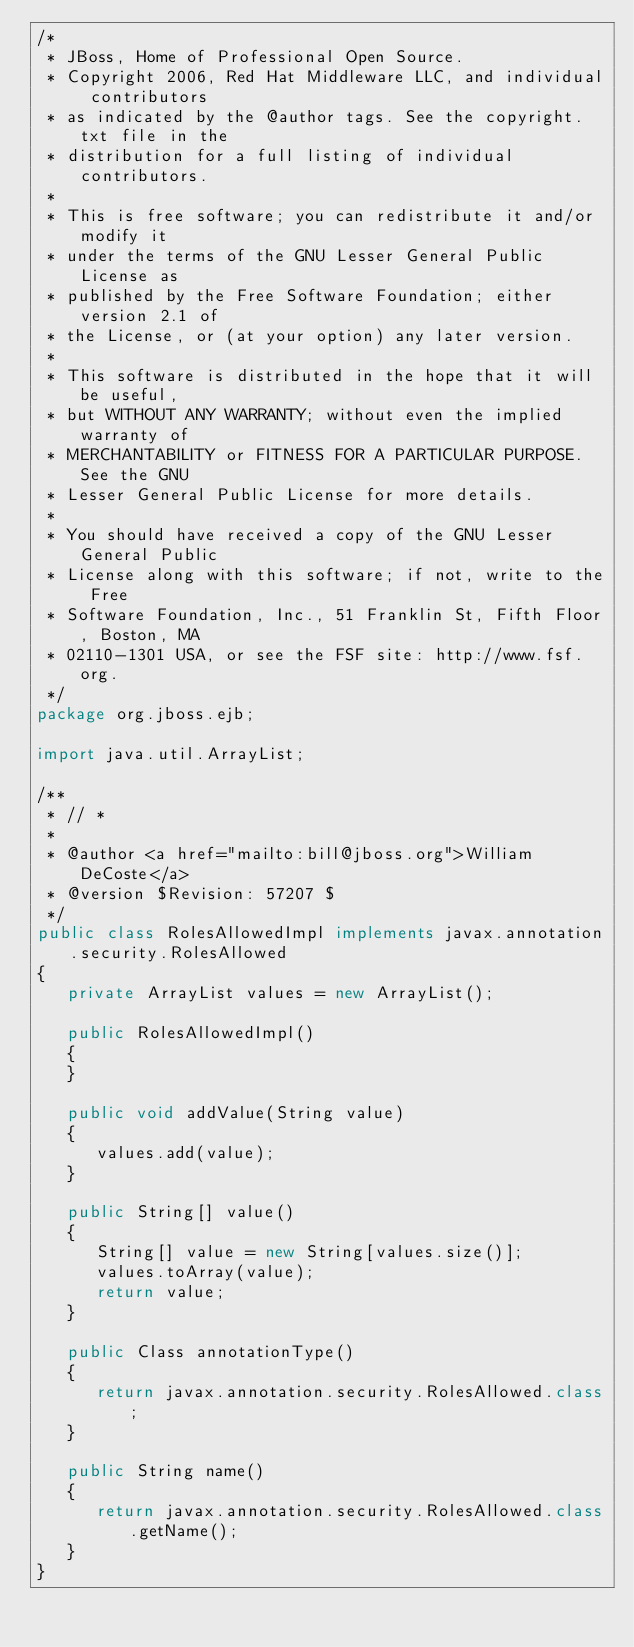<code> <loc_0><loc_0><loc_500><loc_500><_Java_>/*
 * JBoss, Home of Professional Open Source.
 * Copyright 2006, Red Hat Middleware LLC, and individual contributors
 * as indicated by the @author tags. See the copyright.txt file in the
 * distribution for a full listing of individual contributors.
 *
 * This is free software; you can redistribute it and/or modify it
 * under the terms of the GNU Lesser General Public License as
 * published by the Free Software Foundation; either version 2.1 of
 * the License, or (at your option) any later version.
 *
 * This software is distributed in the hope that it will be useful,
 * but WITHOUT ANY WARRANTY; without even the implied warranty of
 * MERCHANTABILITY or FITNESS FOR A PARTICULAR PURPOSE. See the GNU
 * Lesser General Public License for more details.
 *
 * You should have received a copy of the GNU Lesser General Public
 * License along with this software; if not, write to the Free
 * Software Foundation, Inc., 51 Franklin St, Fifth Floor, Boston, MA
 * 02110-1301 USA, or see the FSF site: http://www.fsf.org.
 */
package org.jboss.ejb;

import java.util.ArrayList;

/**
 * // *
 *
 * @author <a href="mailto:bill@jboss.org">William DeCoste</a>
 * @version $Revision: 57207 $
 */
public class RolesAllowedImpl implements javax.annotation.security.RolesAllowed
{
   private ArrayList values = new ArrayList();

   public RolesAllowedImpl()
   {
   }

   public void addValue(String value)
   {
      values.add(value);
   }

   public String[] value()
   {
      String[] value = new String[values.size()];
      values.toArray(value);
      return value;
   }

   public Class annotationType()
   {
      return javax.annotation.security.RolesAllowed.class;
   }

   public String name()
   {
      return javax.annotation.security.RolesAllowed.class.getName();
   }
}
</code> 